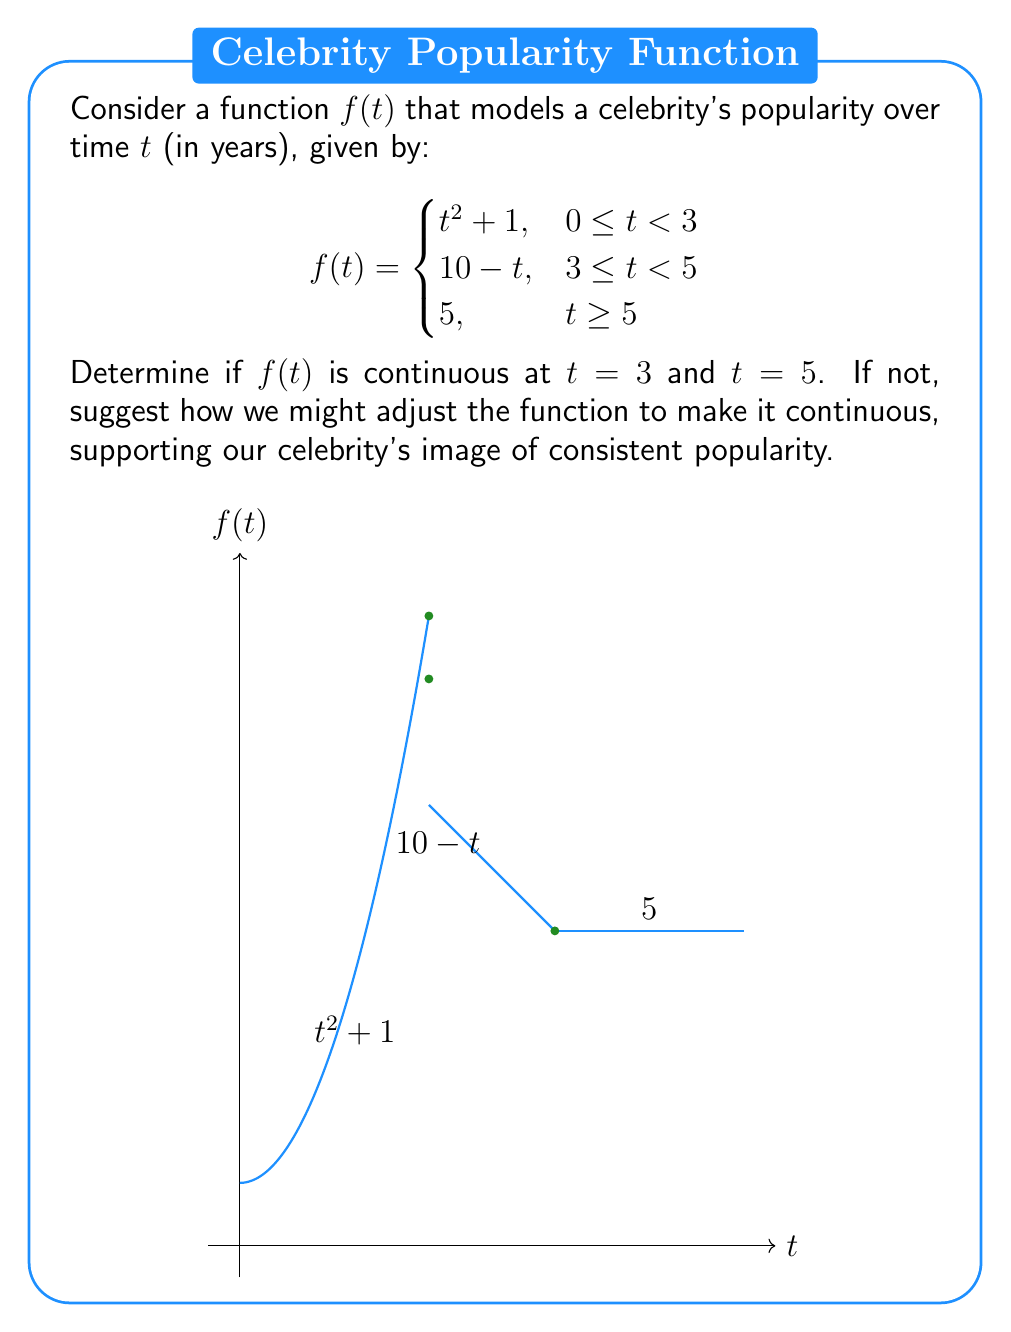Could you help me with this problem? Let's examine the continuity at $t = 3$ and $t = 5$ separately:

1. Continuity at $t = 3$:
   For a function to be continuous at a point, the limit from both sides must exist and be equal to the function value at that point.

   Left limit: $\lim_{t \to 3^-} f(t) = \lim_{t \to 3^-} (t^2 + 1) = 3^2 + 1 = 10$
   Right limit: $\lim_{t \to 3^+} f(t) = \lim_{t \to 3^+} (10 - t) = 10 - 3 = 7$
   Function value: $f(3) = 10 - 3 = 7$

   The left limit (10) does not equal the right limit (7), so $f(t)$ is not continuous at $t = 3$.

2. Continuity at $t = 5$:
   Left limit: $\lim_{t \to 5^-} f(t) = \lim_{t \to 5^-} (10 - t) = 10 - 5 = 5$
   Right limit: $\lim_{t \to 5^+} f(t) = 5$
   Function value: $f(5) = 5$

   All three values are equal, so $f(t)$ is continuous at $t = 5$.

To make the function continuous at $t = 3$, we could adjust it as follows:

$$f(t) = \begin{cases}
t^2 + 1, & 0 \leq t < 3 \\
-t^2 + 13, & 3 \leq t < 5 \\
5, & t \geq 5
\end{cases}$$

This adjustment ensures that $f(3) = 3^2 + 1 = 10$ from both sides, creating a smooth transition in the celebrity's popularity function.
Answer: Continuous at $t = 5$, discontinuous at $t = 3$. 